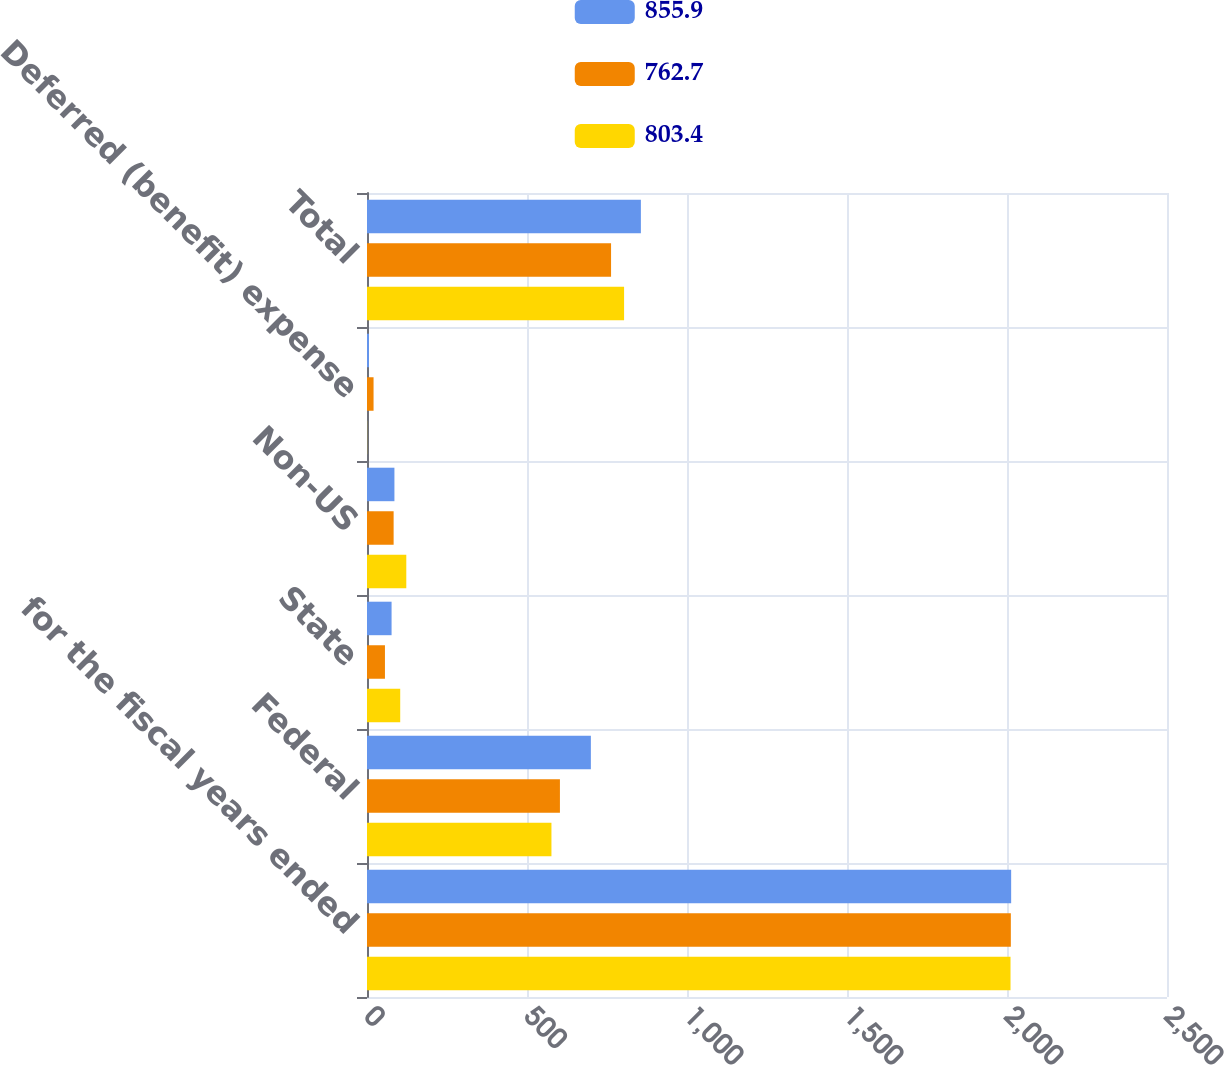<chart> <loc_0><loc_0><loc_500><loc_500><stacked_bar_chart><ecel><fcel>for the fiscal years ended<fcel>Federal<fcel>State<fcel>Non-US<fcel>Deferred (benefit) expense<fcel>Total<nl><fcel>855.9<fcel>2013<fcel>699.6<fcel>76.8<fcel>85.7<fcel>6.2<fcel>855.9<nl><fcel>762.7<fcel>2012<fcel>602.9<fcel>56.1<fcel>83.2<fcel>20.5<fcel>762.7<nl><fcel>803.4<fcel>2011<fcel>576.4<fcel>103.8<fcel>122.8<fcel>0.4<fcel>803.4<nl></chart> 